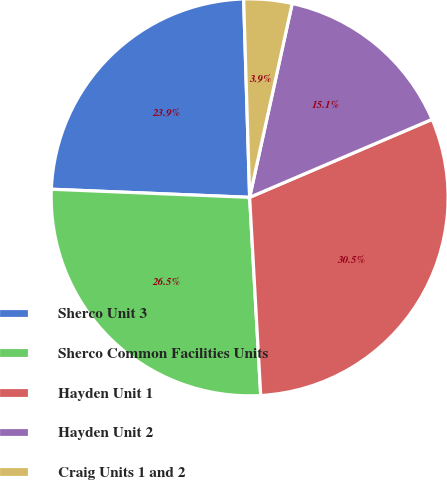<chart> <loc_0><loc_0><loc_500><loc_500><pie_chart><fcel>Sherco Unit 3<fcel>Sherco Common Facilities Units<fcel>Hayden Unit 1<fcel>Hayden Unit 2<fcel>Craig Units 1 and 2<nl><fcel>23.87%<fcel>26.54%<fcel>30.54%<fcel>15.13%<fcel>3.92%<nl></chart> 